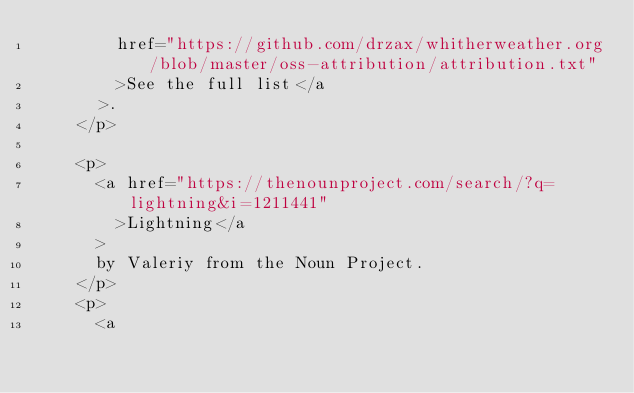Convert code to text. <code><loc_0><loc_0><loc_500><loc_500><_HTML_>        href="https://github.com/drzax/whitherweather.org/blob/master/oss-attribution/attribution.txt"
        >See the full list</a
      >.
    </p>

    <p>
      <a href="https://thenounproject.com/search/?q=lightning&i=1211441"
        >Lightning</a
      >
      by Valeriy from the Noun Project.
    </p>
    <p>
      <a</code> 